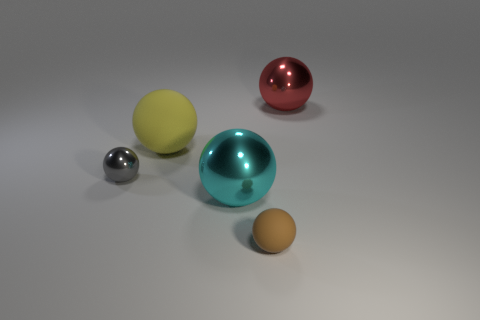Subtract all large spheres. How many spheres are left? 2 Subtract all brown spheres. How many spheres are left? 4 Add 2 big red metal objects. How many objects exist? 7 Subtract 1 spheres. How many spheres are left? 4 Subtract all cyan cubes. How many green spheres are left? 0 Add 4 cyan metal balls. How many cyan metal balls exist? 5 Subtract 0 cyan cylinders. How many objects are left? 5 Subtract all yellow balls. Subtract all yellow cubes. How many balls are left? 4 Subtract all small balls. Subtract all metal objects. How many objects are left? 0 Add 4 large yellow matte balls. How many large yellow matte balls are left? 5 